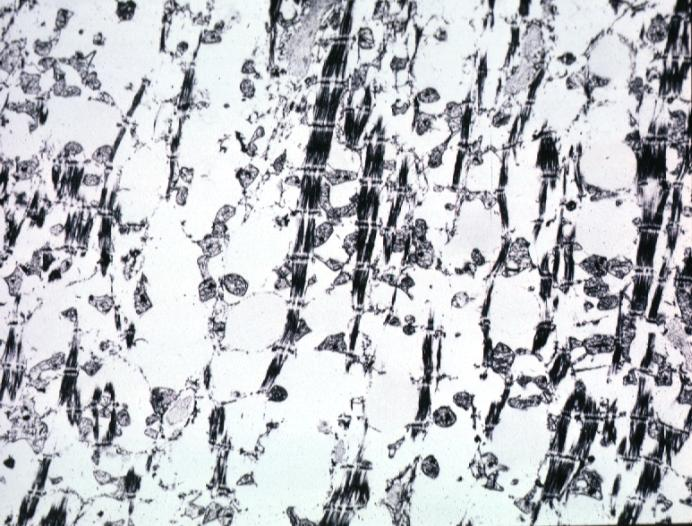s cardiovascular present?
Answer the question using a single word or phrase. No 